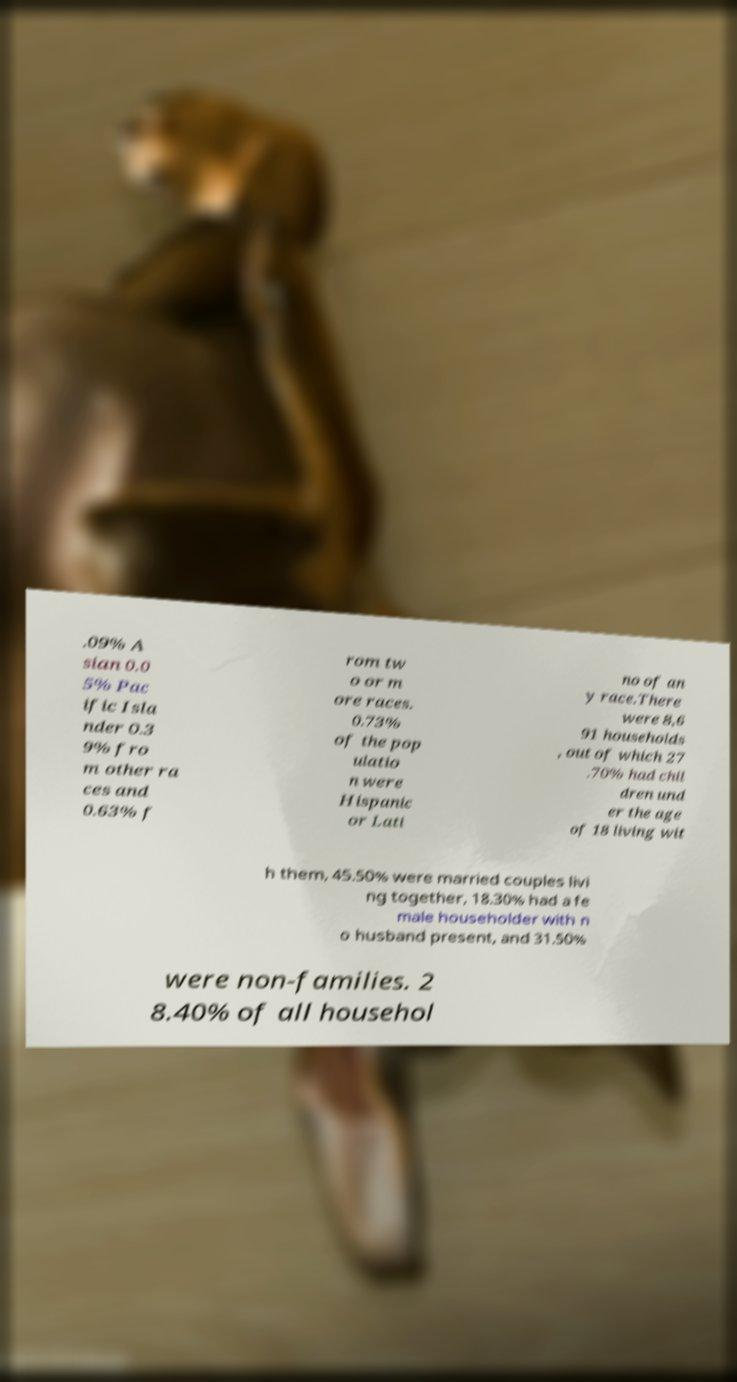There's text embedded in this image that I need extracted. Can you transcribe it verbatim? .09% A sian 0.0 5% Pac ific Isla nder 0.3 9% fro m other ra ces and 0.63% f rom tw o or m ore races. 0.73% of the pop ulatio n were Hispanic or Lati no of an y race.There were 8,6 91 households , out of which 27 .70% had chil dren und er the age of 18 living wit h them, 45.50% were married couples livi ng together, 18.30% had a fe male householder with n o husband present, and 31.50% were non-families. 2 8.40% of all househol 